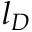Convert formula to latex. <formula><loc_0><loc_0><loc_500><loc_500>l _ { D }</formula> 